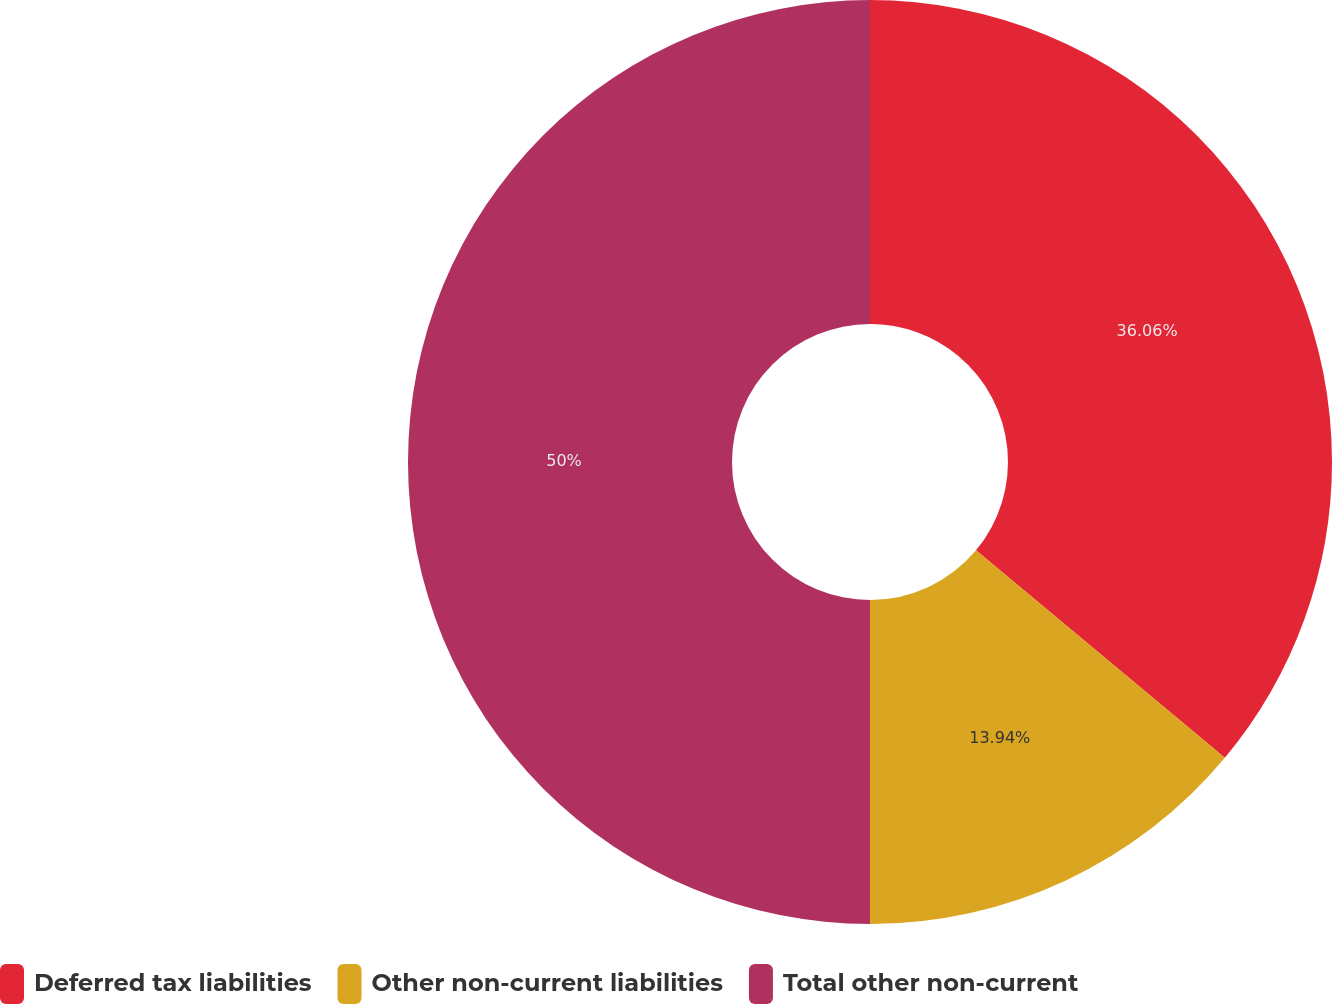<chart> <loc_0><loc_0><loc_500><loc_500><pie_chart><fcel>Deferred tax liabilities<fcel>Other non-current liabilities<fcel>Total other non-current<nl><fcel>36.06%<fcel>13.94%<fcel>50.0%<nl></chart> 